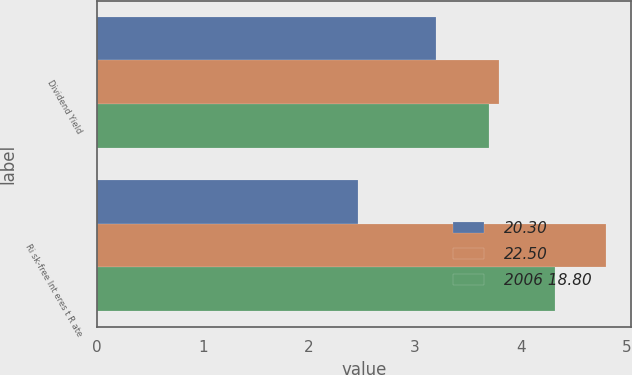Convert chart to OTSL. <chart><loc_0><loc_0><loc_500><loc_500><stacked_bar_chart><ecel><fcel>Dividend Yield<fcel>Ri sk-free Int eres t R ate<nl><fcel>20.30<fcel>3.2<fcel>2.46<nl><fcel>22.50<fcel>3.79<fcel>4.8<nl><fcel>2006 18.80<fcel>3.7<fcel>4.32<nl></chart> 